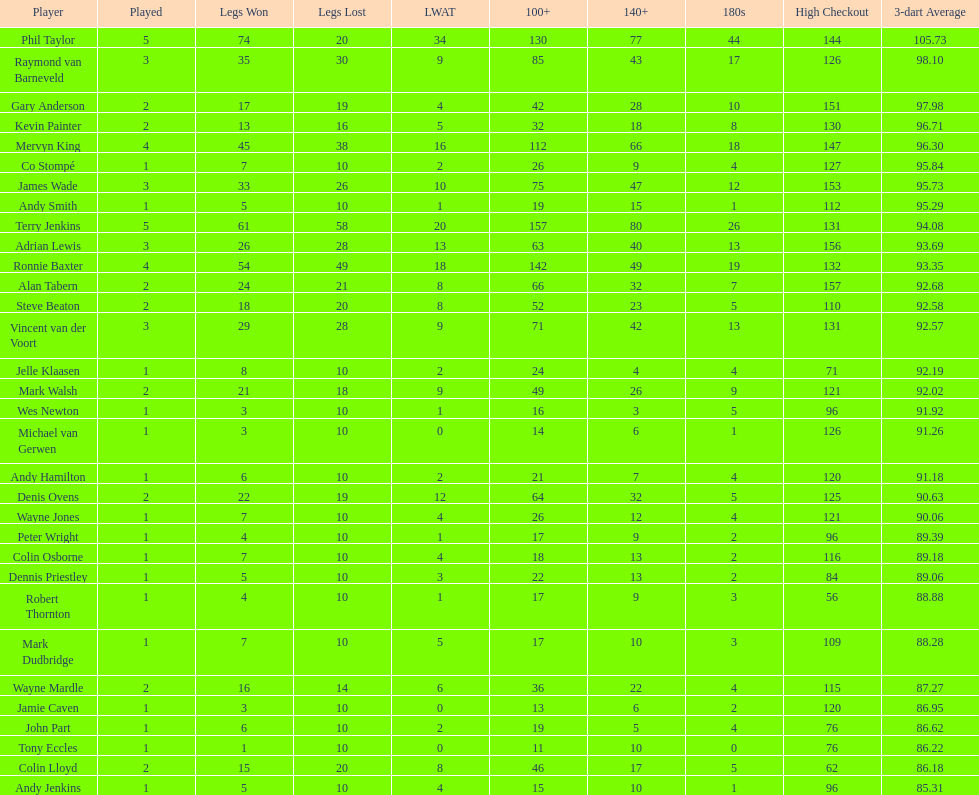Could you parse the entire table? {'header': ['Player', 'Played', 'Legs Won', 'Legs Lost', 'LWAT', '100+', '140+', '180s', 'High Checkout', '3-dart Average'], 'rows': [['Phil Taylor', '5', '74', '20', '34', '130', '77', '44', '144', '105.73'], ['Raymond van Barneveld', '3', '35', '30', '9', '85', '43', '17', '126', '98.10'], ['Gary Anderson', '2', '17', '19', '4', '42', '28', '10', '151', '97.98'], ['Kevin Painter', '2', '13', '16', '5', '32', '18', '8', '130', '96.71'], ['Mervyn King', '4', '45', '38', '16', '112', '66', '18', '147', '96.30'], ['Co Stompé', '1', '7', '10', '2', '26', '9', '4', '127', '95.84'], ['James Wade', '3', '33', '26', '10', '75', '47', '12', '153', '95.73'], ['Andy Smith', '1', '5', '10', '1', '19', '15', '1', '112', '95.29'], ['Terry Jenkins', '5', '61', '58', '20', '157', '80', '26', '131', '94.08'], ['Adrian Lewis', '3', '26', '28', '13', '63', '40', '13', '156', '93.69'], ['Ronnie Baxter', '4', '54', '49', '18', '142', '49', '19', '132', '93.35'], ['Alan Tabern', '2', '24', '21', '8', '66', '32', '7', '157', '92.68'], ['Steve Beaton', '2', '18', '20', '8', '52', '23', '5', '110', '92.58'], ['Vincent van der Voort', '3', '29', '28', '9', '71', '42', '13', '131', '92.57'], ['Jelle Klaasen', '1', '8', '10', '2', '24', '4', '4', '71', '92.19'], ['Mark Walsh', '2', '21', '18', '9', '49', '26', '9', '121', '92.02'], ['Wes Newton', '1', '3', '10', '1', '16', '3', '5', '96', '91.92'], ['Michael van Gerwen', '1', '3', '10', '0', '14', '6', '1', '126', '91.26'], ['Andy Hamilton', '1', '6', '10', '2', '21', '7', '4', '120', '91.18'], ['Denis Ovens', '2', '22', '19', '12', '64', '32', '5', '125', '90.63'], ['Wayne Jones', '1', '7', '10', '4', '26', '12', '4', '121', '90.06'], ['Peter Wright', '1', '4', '10', '1', '17', '9', '2', '96', '89.39'], ['Colin Osborne', '1', '7', '10', '4', '18', '13', '2', '116', '89.18'], ['Dennis Priestley', '1', '5', '10', '3', '22', '13', '2', '84', '89.06'], ['Robert Thornton', '1', '4', '10', '1', '17', '9', '3', '56', '88.88'], ['Mark Dudbridge', '1', '7', '10', '5', '17', '10', '3', '109', '88.28'], ['Wayne Mardle', '2', '16', '14', '6', '36', '22', '4', '115', '87.27'], ['Jamie Caven', '1', '3', '10', '0', '13', '6', '2', '120', '86.95'], ['John Part', '1', '6', '10', '2', '19', '5', '4', '76', '86.62'], ['Tony Eccles', '1', '1', '10', '0', '11', '10', '0', '76', '86.22'], ['Colin Lloyd', '2', '15', '20', '8', '46', '17', '5', '62', '86.18'], ['Andy Jenkins', '1', '5', '10', '4', '15', '10', '1', '96', '85.31']]} Who is the player following mark walsh? Wes Newton. 